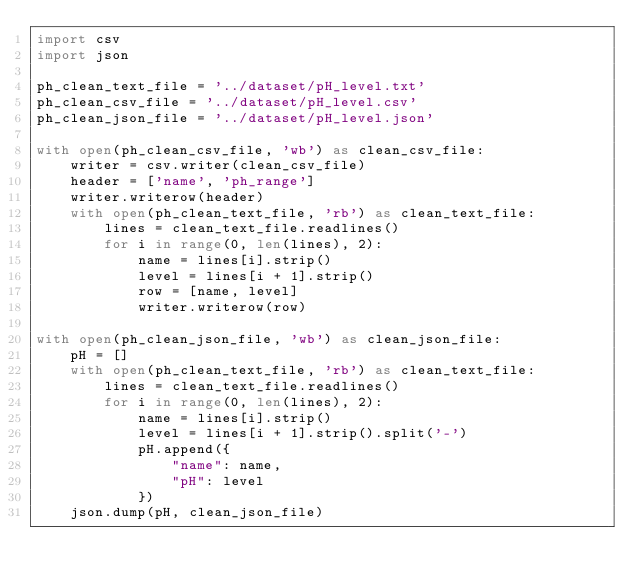<code> <loc_0><loc_0><loc_500><loc_500><_Python_>import csv
import json

ph_clean_text_file = '../dataset/pH_level.txt'
ph_clean_csv_file = '../dataset/pH_level.csv'
ph_clean_json_file = '../dataset/pH_level.json'

with open(ph_clean_csv_file, 'wb') as clean_csv_file:
    writer = csv.writer(clean_csv_file)
    header = ['name', 'ph_range']
    writer.writerow(header)
    with open(ph_clean_text_file, 'rb') as clean_text_file:
        lines = clean_text_file.readlines()
        for i in range(0, len(lines), 2):
            name = lines[i].strip()
            level = lines[i + 1].strip()
            row = [name, level]
            writer.writerow(row)

with open(ph_clean_json_file, 'wb') as clean_json_file:
    pH = []
    with open(ph_clean_text_file, 'rb') as clean_text_file:
        lines = clean_text_file.readlines()
        for i in range(0, len(lines), 2):
            name = lines[i].strip()
            level = lines[i + 1].strip().split('-')
            pH.append({
                "name": name,
                "pH": level
            })
    json.dump(pH, clean_json_file)
</code> 